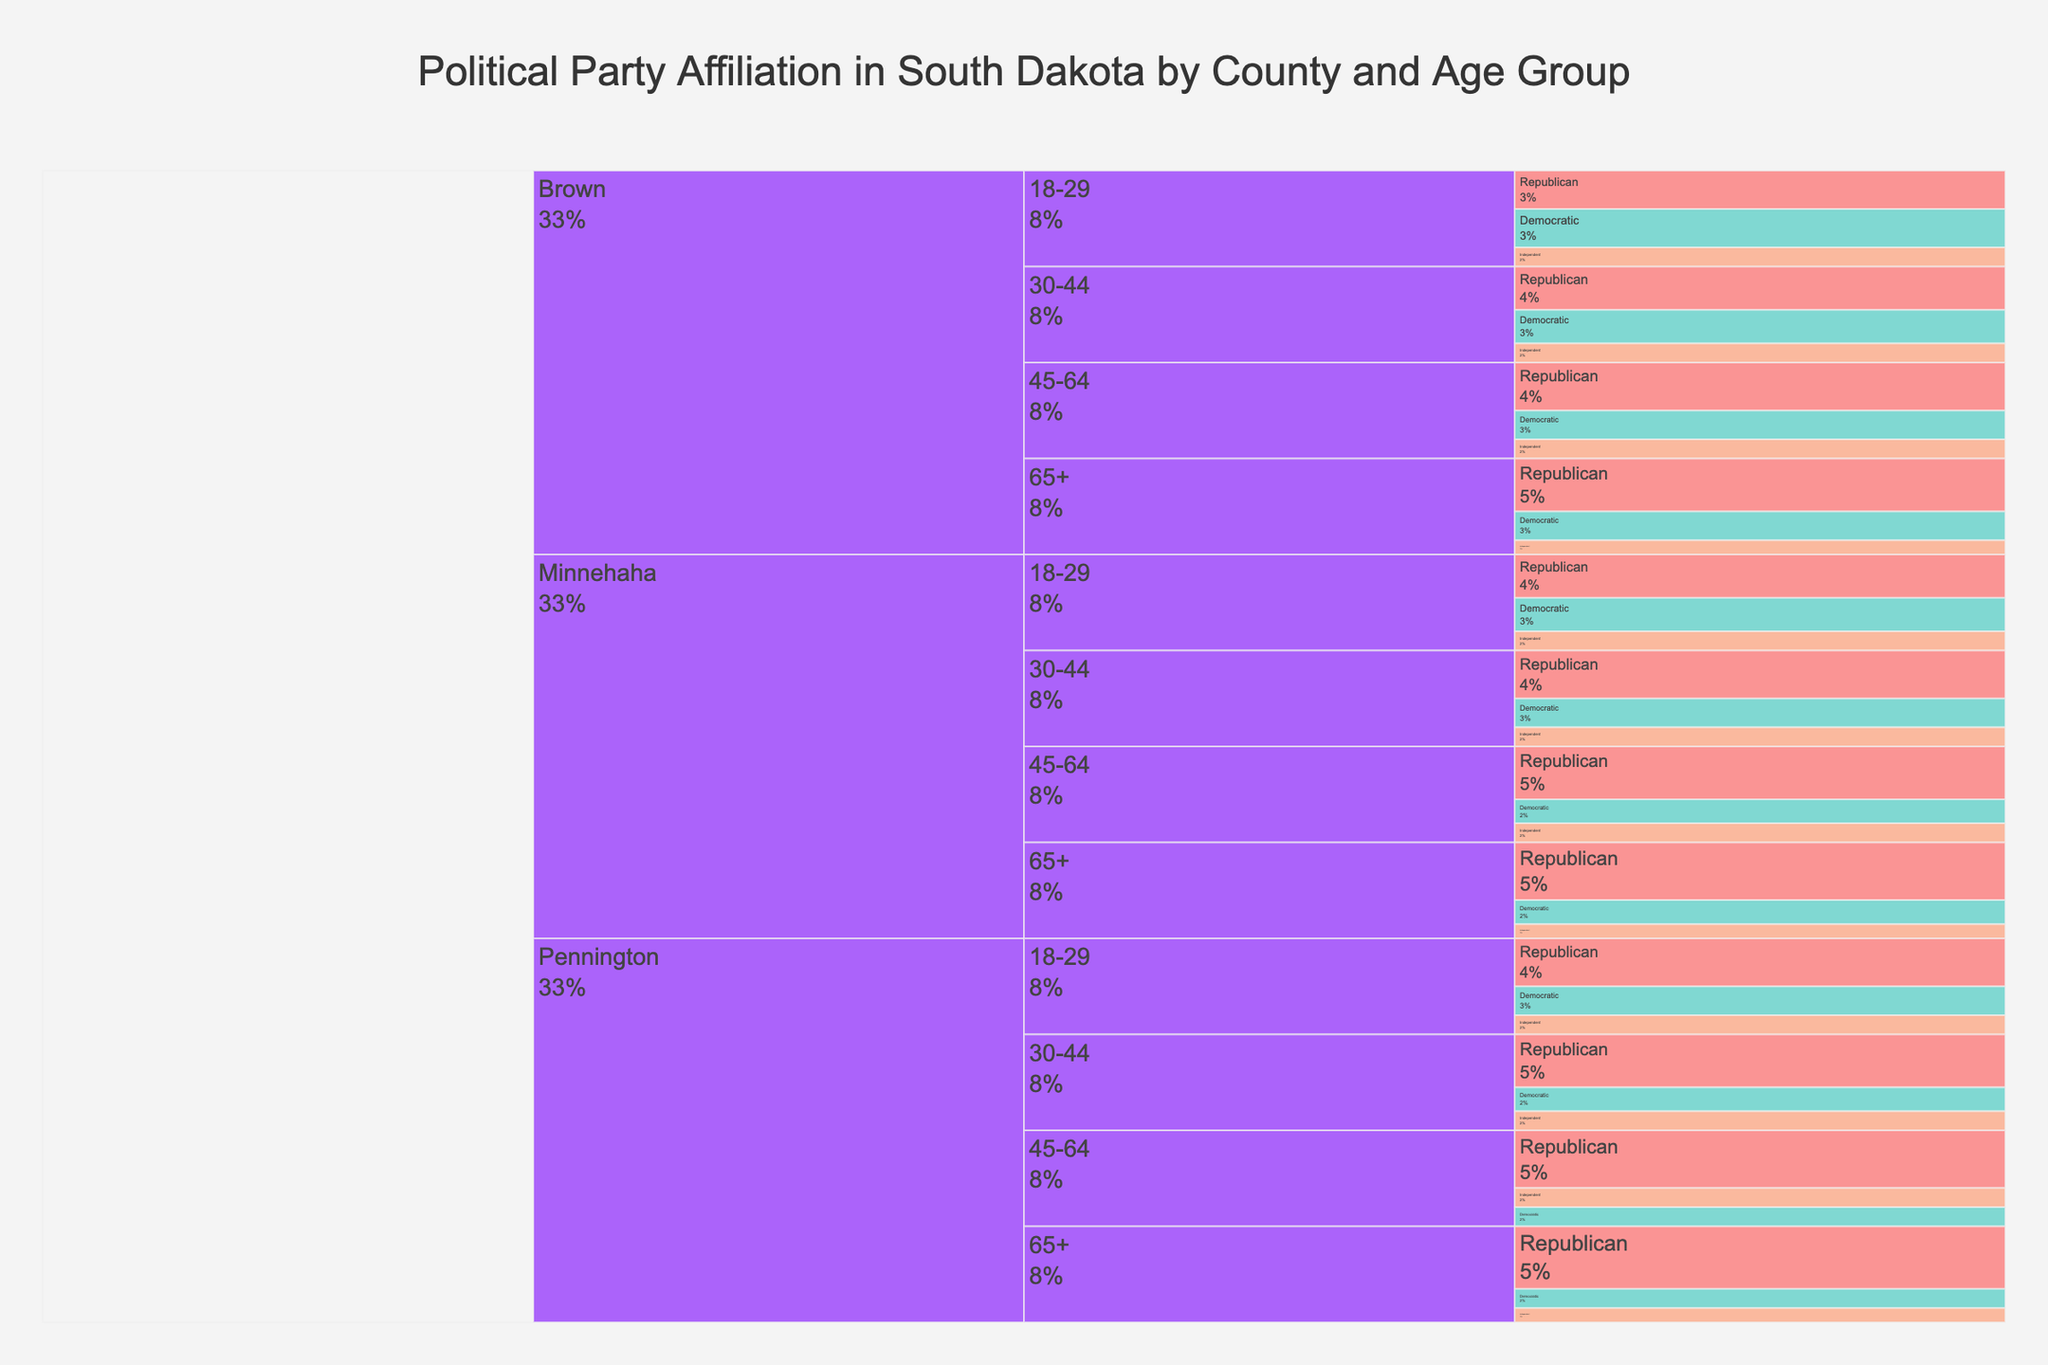what is the percentage of Republican affiliation for the age group 18-29 in Minnehaha county? In the icicle chart, locate the branch for Minnehaha county and then the sub-branch for the age group 18-29. Check the segment corresponding to the Republican affiliation and read off the percentage.
Answer: 45% how does the percentage of Democratic affiliation for the age group 65+ in Pennington county compare to the same age group in Minnehaha county? Locate the branches for Pennington and Minnehaha counties, and then find the age group 65+ in each. Compare the Democratic affiliation percentages.
Answer: Equal what is the overall distribution of party affiliation in Minnehaha county? Sum the percentages for each party affiliation across all age groups in Minnehaha county and divide by the total number of affiliations for that county. This gives the overall distribution across one region.
Answer: Republican 52.5%, Democratic 28.5%, Independent 18.0% which party affiliation has the highest percentage for any age group in Brown county? Scan the data for Brown county segments and compare the percentages across all age groups. Identify the highest percentage regardless of the specific age group.
Answer: Republican 55% is there a trend in Republican affiliation percentages increasing or decreasing by age in Pennington county? In Pennington county, examine the Republican affiliation percentages across the age groups 18-29, 30-44, 45-64, and 65+. Note if the percentages increase or decrease with age.
Answer: Increasing 